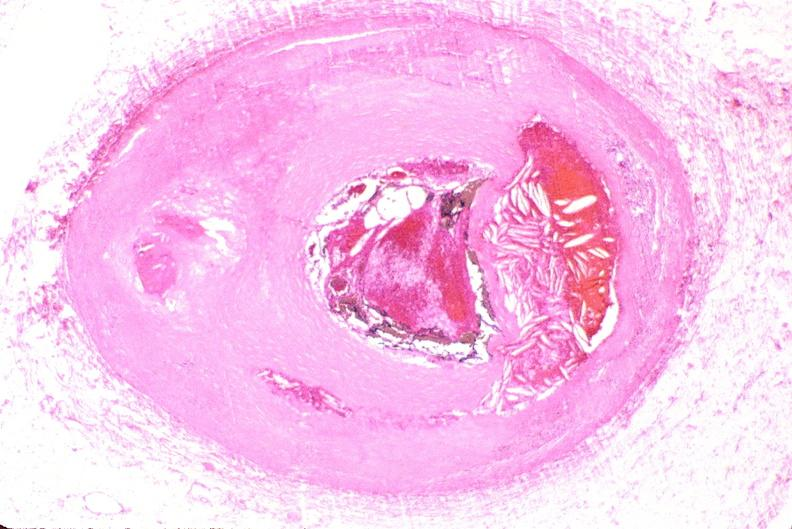what is present?
Answer the question using a single word or phrase. Vasculature 